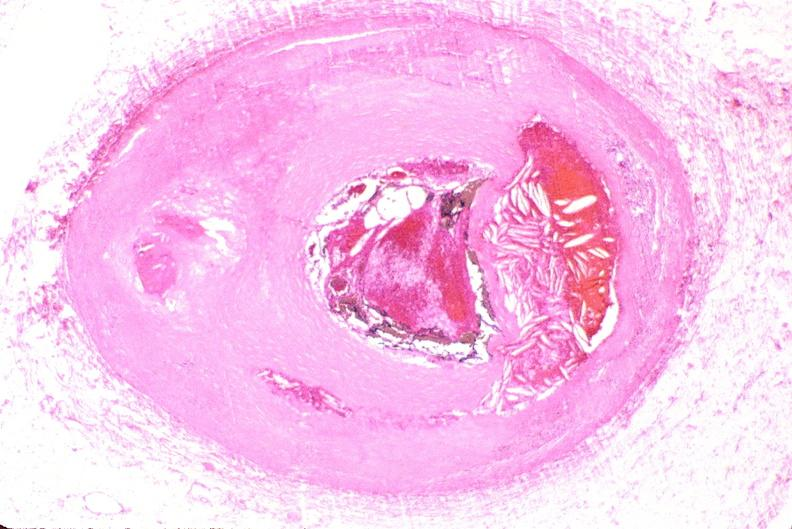what is present?
Answer the question using a single word or phrase. Vasculature 